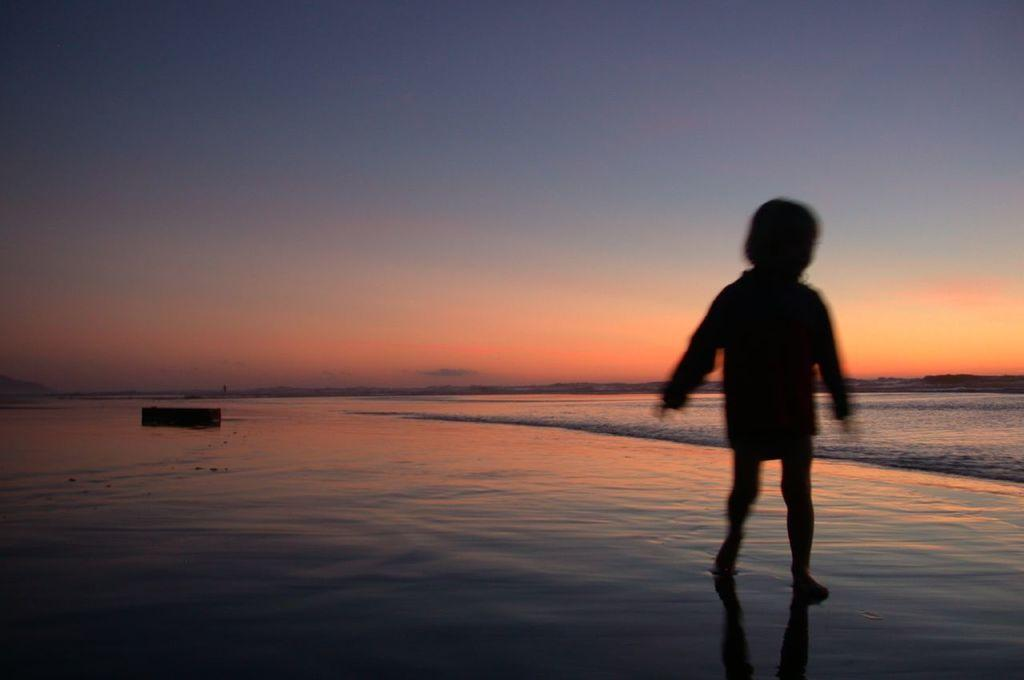What is the main subject of the image? The main subject of the image is a kid. What is the kid doing in the image? The kid is standing in the image. Where is the location of the image? The location of the image is a beach. How many toes can be seen on the women in the image? There are no women present in the image, only a kid. What scientific theory is being discussed in the image? There is no discussion of any scientific theory in the image; it features a kid standing at a beach. 